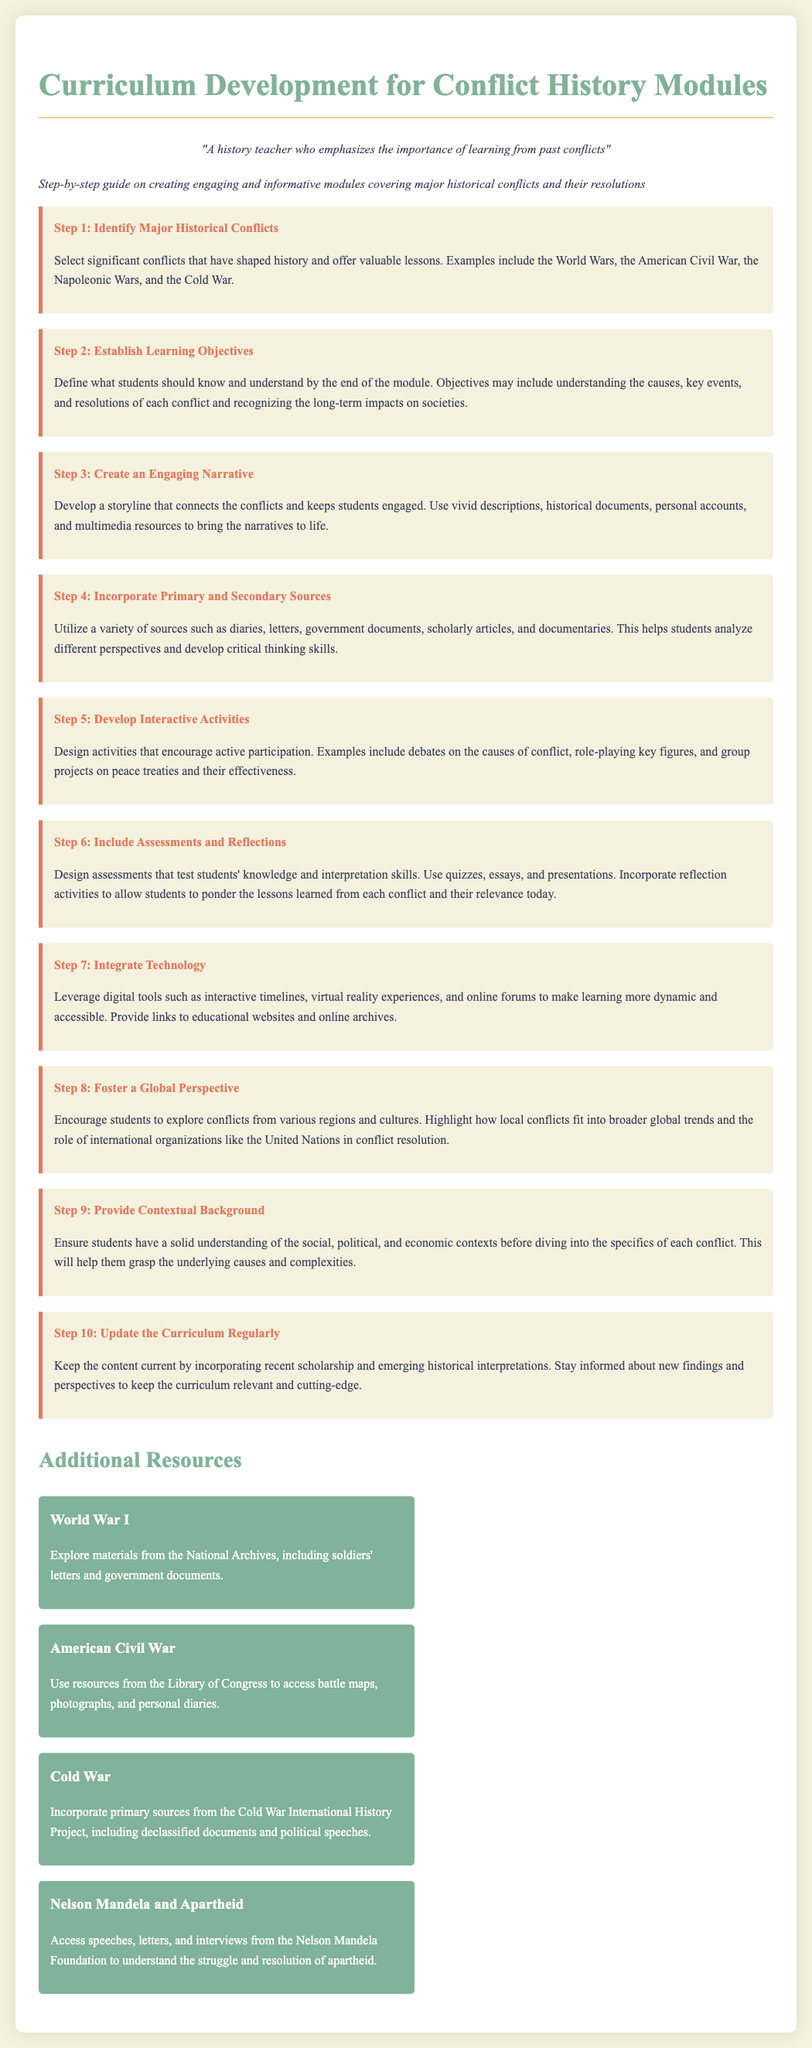What is the title of the document? The title is indicated at the top of the document, summarizing the main topic and purpose.
Answer: Curriculum Development for Conflict History Modules What is the first step in creating the modules? The first step is specified in the steps section, focusing on identifying significant historical events.
Answer: Identify Major Historical Conflicts How many main steps are outlined for creating the modules? The document lists a total number of main steps in the curriculum development process.
Answer: Ten What should students analyze in Step 4? Step 4 describes the types of sources that should be used to enhance critical thinking skills among students.
Answer: Primary and Secondary Sources What educational tool is mentioned in Step 7? The technology used to enhance learning is detailed in Step 7, which discusses its integration into curriculum development.
Answer: Virtual Reality Experiences Which conflict is mentioned in the additional resources section? The document lists various significant conflicts along with resources; one example is provided for historical research.
Answer: Cold War What is the suggested activity type in Step 5? Step 5 highlights types of activities that promote engagement among students during the learning process.
Answer: Role-playing key figures In which step should background context be provided? The step that emphasizes the importance of user understanding before discussing specific conflicts is clearly indicated.
Answer: Step 9 What organization is mentioned in Step 8 regarding conflict resolution? A global organization is referenced to illustrate its involvement in resolving conflicts highlighted in the curriculum.
Answer: United Nations 